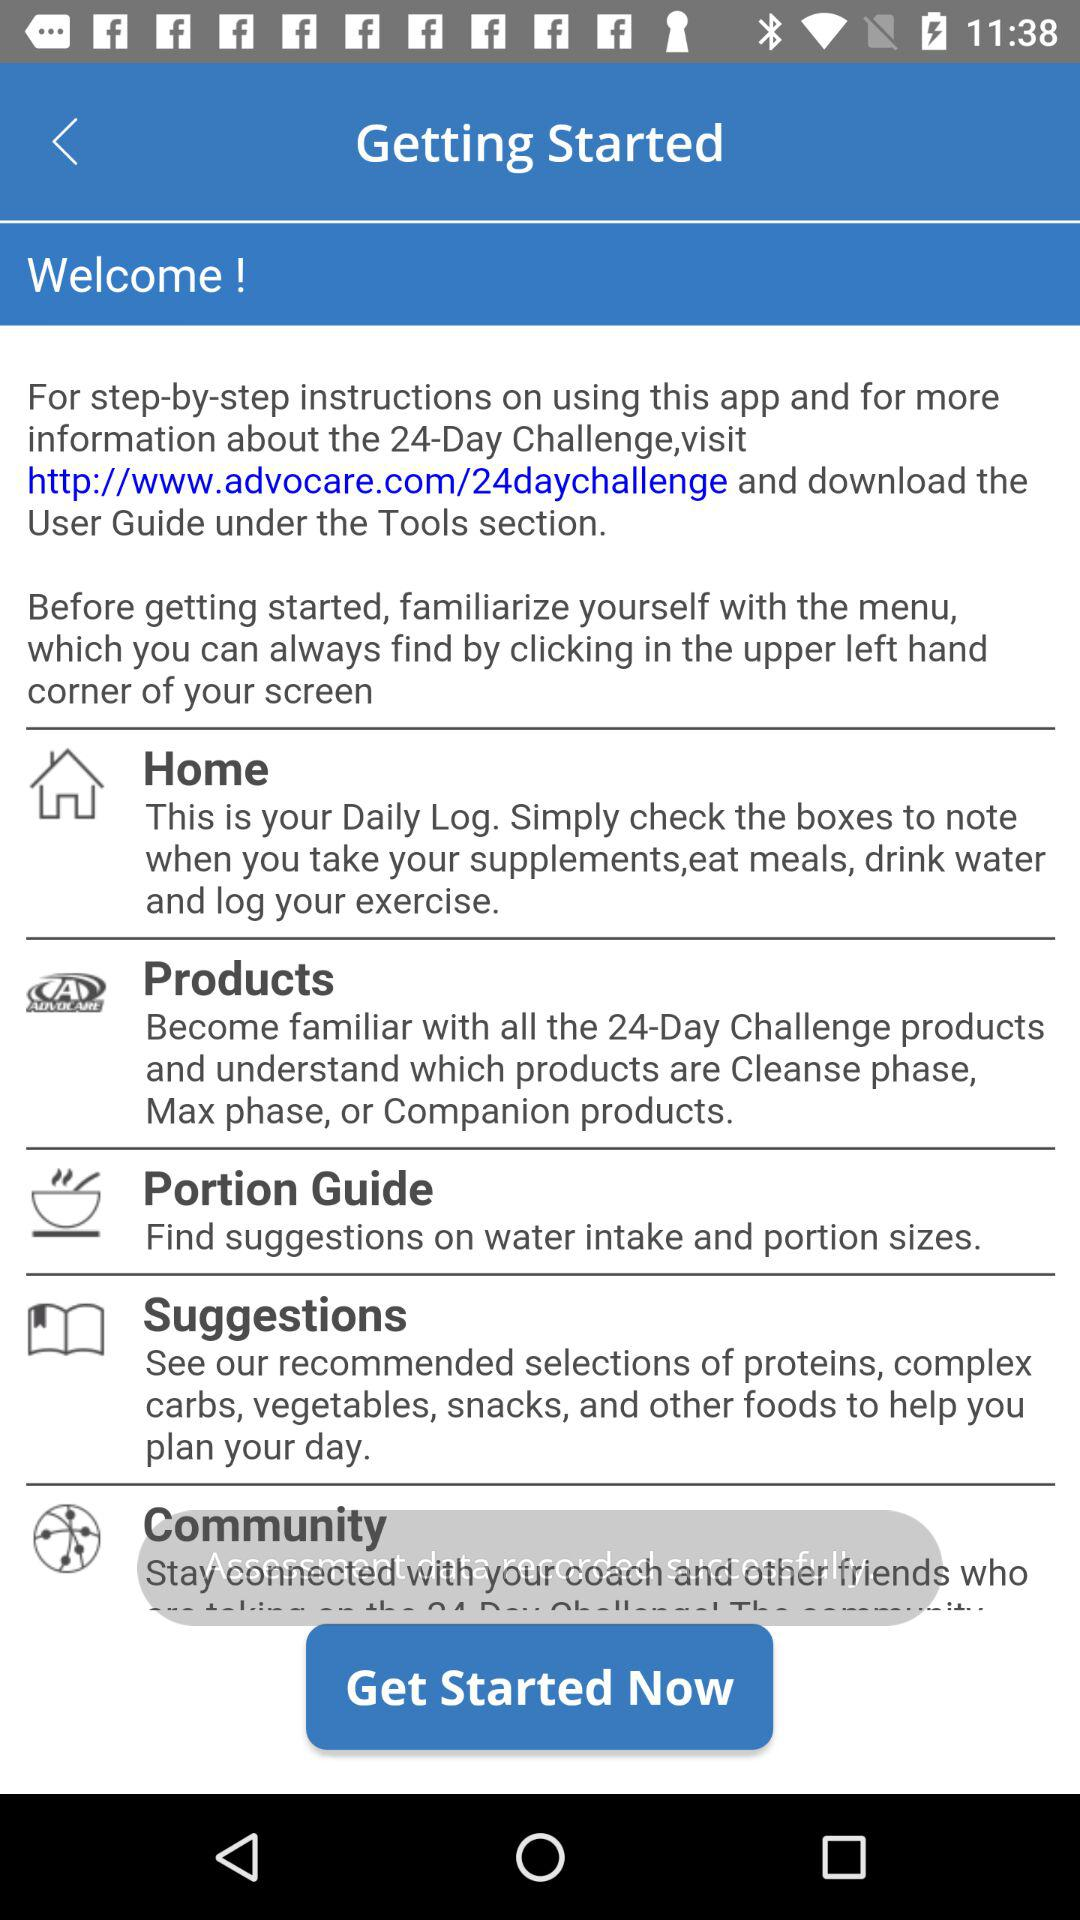How many items are in the menu?
Answer the question using a single word or phrase. 5 